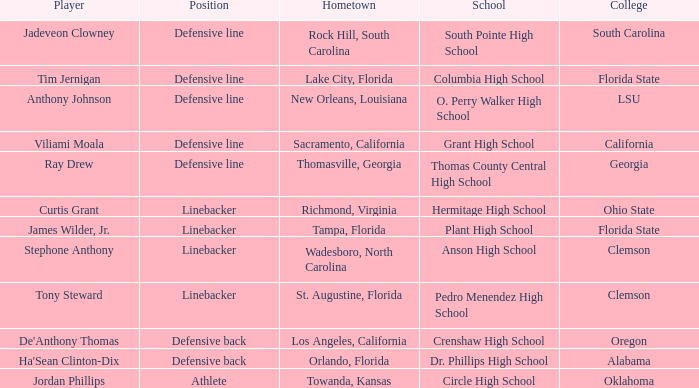What position is for Dr. Phillips high school? Defensive back. 